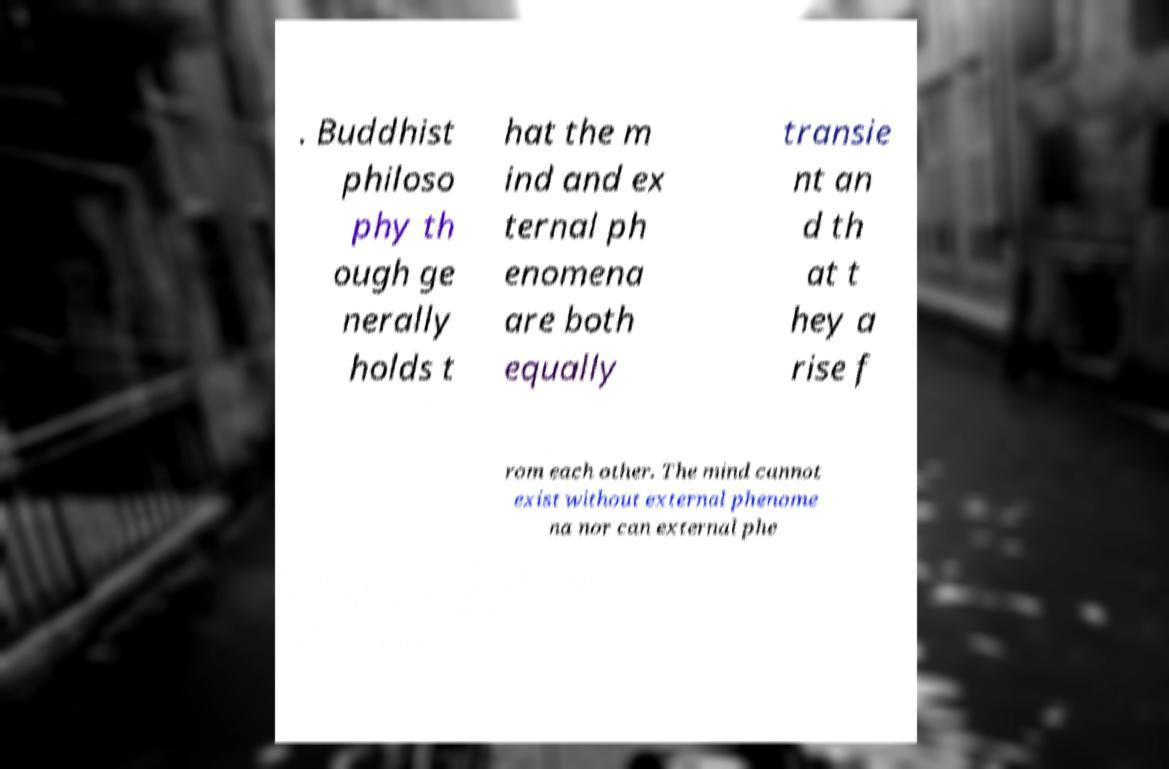Could you assist in decoding the text presented in this image and type it out clearly? . Buddhist philoso phy th ough ge nerally holds t hat the m ind and ex ternal ph enomena are both equally transie nt an d th at t hey a rise f rom each other. The mind cannot exist without external phenome na nor can external phe 